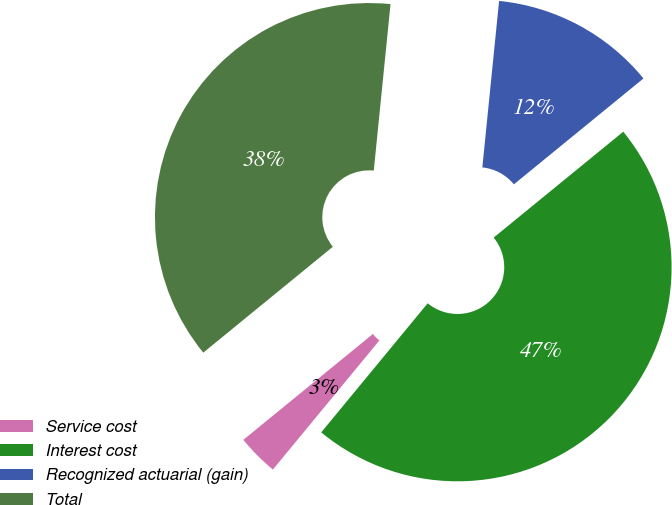Convert chart to OTSL. <chart><loc_0><loc_0><loc_500><loc_500><pie_chart><fcel>Service cost<fcel>Interest cost<fcel>Recognized actuarial (gain)<fcel>Total<nl><fcel>3.12%<fcel>46.88%<fcel>12.5%<fcel>37.5%<nl></chart> 